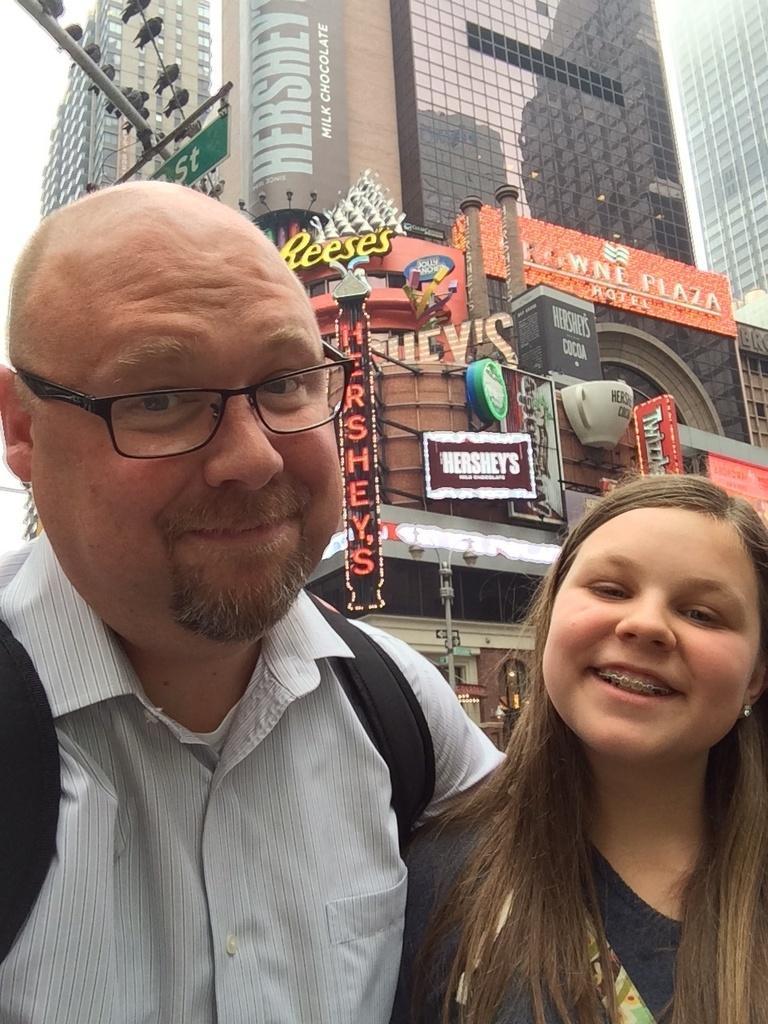Please provide a concise description of this image. In the picture I can see a man and a woman are standing and smiling. In the background I can see buildings, LED boards on which there is something written on them and some other objects. On the left side I can see birds. 